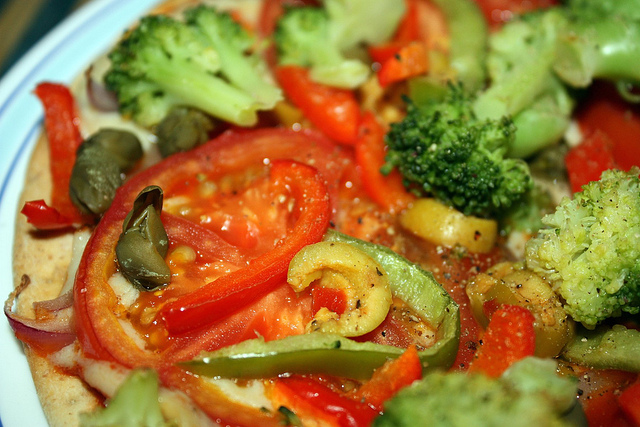Can you describe the vegetables present besides broccoli? Certainly! Alongside the broccoli, there are slices of juicy red tomatoes, strips of bell peppers in various colors, such as green and red, as well as what appears to be pieces of mushrooms and olives, all arranged on what seems to be a flatbread or pizza base. 